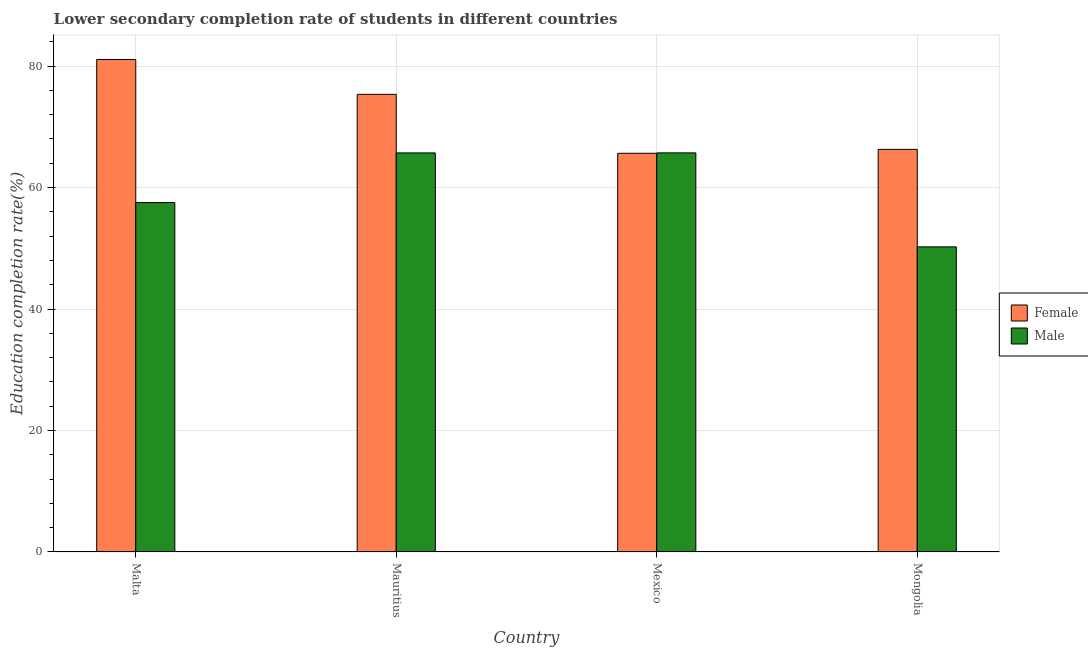How many groups of bars are there?
Offer a terse response. 4. Are the number of bars on each tick of the X-axis equal?
Your answer should be very brief. Yes. How many bars are there on the 2nd tick from the right?
Offer a very short reply. 2. What is the label of the 1st group of bars from the left?
Ensure brevity in your answer.  Malta. In how many cases, is the number of bars for a given country not equal to the number of legend labels?
Ensure brevity in your answer.  0. What is the education completion rate of male students in Mauritius?
Offer a very short reply. 65.71. Across all countries, what is the maximum education completion rate of female students?
Your answer should be compact. 81.09. Across all countries, what is the minimum education completion rate of male students?
Provide a short and direct response. 50.24. In which country was the education completion rate of female students maximum?
Your answer should be very brief. Malta. What is the total education completion rate of male students in the graph?
Make the answer very short. 239.2. What is the difference between the education completion rate of male students in Malta and that in Mongolia?
Your response must be concise. 7.3. What is the difference between the education completion rate of male students in Mexico and the education completion rate of female students in Mauritius?
Provide a succinct answer. -9.64. What is the average education completion rate of female students per country?
Your response must be concise. 72.09. What is the difference between the education completion rate of male students and education completion rate of female students in Mauritius?
Make the answer very short. -9.64. What is the ratio of the education completion rate of female students in Malta to that in Mexico?
Keep it short and to the point. 1.24. What is the difference between the highest and the second highest education completion rate of male students?
Offer a very short reply. 0.01. What is the difference between the highest and the lowest education completion rate of male students?
Offer a very short reply. 15.48. In how many countries, is the education completion rate of female students greater than the average education completion rate of female students taken over all countries?
Ensure brevity in your answer.  2. What does the 2nd bar from the left in Malta represents?
Offer a terse response. Male. What does the 1st bar from the right in Mongolia represents?
Keep it short and to the point. Male. How many bars are there?
Give a very brief answer. 8. Are all the bars in the graph horizontal?
Offer a terse response. No. What is the difference between two consecutive major ticks on the Y-axis?
Your answer should be very brief. 20. Does the graph contain grids?
Ensure brevity in your answer.  Yes. Where does the legend appear in the graph?
Your response must be concise. Center right. How many legend labels are there?
Your answer should be very brief. 2. What is the title of the graph?
Keep it short and to the point. Lower secondary completion rate of students in different countries. Does "Money lenders" appear as one of the legend labels in the graph?
Make the answer very short. No. What is the label or title of the Y-axis?
Your answer should be compact. Education completion rate(%). What is the Education completion rate(%) of Female in Malta?
Make the answer very short. 81.09. What is the Education completion rate(%) of Male in Malta?
Offer a very short reply. 57.54. What is the Education completion rate(%) of Female in Mauritius?
Your response must be concise. 75.35. What is the Education completion rate(%) of Male in Mauritius?
Provide a succinct answer. 65.71. What is the Education completion rate(%) of Female in Mexico?
Make the answer very short. 65.65. What is the Education completion rate(%) of Male in Mexico?
Offer a terse response. 65.72. What is the Education completion rate(%) of Female in Mongolia?
Ensure brevity in your answer.  66.29. What is the Education completion rate(%) in Male in Mongolia?
Make the answer very short. 50.24. Across all countries, what is the maximum Education completion rate(%) in Female?
Make the answer very short. 81.09. Across all countries, what is the maximum Education completion rate(%) in Male?
Your response must be concise. 65.72. Across all countries, what is the minimum Education completion rate(%) of Female?
Provide a succinct answer. 65.65. Across all countries, what is the minimum Education completion rate(%) in Male?
Keep it short and to the point. 50.24. What is the total Education completion rate(%) in Female in the graph?
Provide a succinct answer. 288.38. What is the total Education completion rate(%) in Male in the graph?
Provide a succinct answer. 239.2. What is the difference between the Education completion rate(%) of Female in Malta and that in Mauritius?
Provide a succinct answer. 5.74. What is the difference between the Education completion rate(%) in Male in Malta and that in Mauritius?
Your answer should be compact. -8.17. What is the difference between the Education completion rate(%) in Female in Malta and that in Mexico?
Provide a succinct answer. 15.45. What is the difference between the Education completion rate(%) in Male in Malta and that in Mexico?
Offer a very short reply. -8.18. What is the difference between the Education completion rate(%) of Female in Malta and that in Mongolia?
Ensure brevity in your answer.  14.8. What is the difference between the Education completion rate(%) in Male in Malta and that in Mongolia?
Your answer should be compact. 7.3. What is the difference between the Education completion rate(%) in Female in Mauritius and that in Mexico?
Your response must be concise. 9.71. What is the difference between the Education completion rate(%) in Male in Mauritius and that in Mexico?
Ensure brevity in your answer.  -0.01. What is the difference between the Education completion rate(%) of Female in Mauritius and that in Mongolia?
Ensure brevity in your answer.  9.06. What is the difference between the Education completion rate(%) in Male in Mauritius and that in Mongolia?
Provide a succinct answer. 15.47. What is the difference between the Education completion rate(%) of Female in Mexico and that in Mongolia?
Your response must be concise. -0.64. What is the difference between the Education completion rate(%) in Male in Mexico and that in Mongolia?
Offer a very short reply. 15.48. What is the difference between the Education completion rate(%) of Female in Malta and the Education completion rate(%) of Male in Mauritius?
Keep it short and to the point. 15.38. What is the difference between the Education completion rate(%) of Female in Malta and the Education completion rate(%) of Male in Mexico?
Make the answer very short. 15.37. What is the difference between the Education completion rate(%) of Female in Malta and the Education completion rate(%) of Male in Mongolia?
Ensure brevity in your answer.  30.85. What is the difference between the Education completion rate(%) in Female in Mauritius and the Education completion rate(%) in Male in Mexico?
Provide a succinct answer. 9.64. What is the difference between the Education completion rate(%) of Female in Mauritius and the Education completion rate(%) of Male in Mongolia?
Give a very brief answer. 25.11. What is the difference between the Education completion rate(%) in Female in Mexico and the Education completion rate(%) in Male in Mongolia?
Provide a short and direct response. 15.41. What is the average Education completion rate(%) in Female per country?
Your response must be concise. 72.09. What is the average Education completion rate(%) in Male per country?
Offer a terse response. 59.8. What is the difference between the Education completion rate(%) of Female and Education completion rate(%) of Male in Malta?
Your answer should be compact. 23.56. What is the difference between the Education completion rate(%) of Female and Education completion rate(%) of Male in Mauritius?
Ensure brevity in your answer.  9.64. What is the difference between the Education completion rate(%) of Female and Education completion rate(%) of Male in Mexico?
Give a very brief answer. -0.07. What is the difference between the Education completion rate(%) of Female and Education completion rate(%) of Male in Mongolia?
Give a very brief answer. 16.05. What is the ratio of the Education completion rate(%) of Female in Malta to that in Mauritius?
Ensure brevity in your answer.  1.08. What is the ratio of the Education completion rate(%) of Male in Malta to that in Mauritius?
Your response must be concise. 0.88. What is the ratio of the Education completion rate(%) in Female in Malta to that in Mexico?
Your answer should be very brief. 1.24. What is the ratio of the Education completion rate(%) of Male in Malta to that in Mexico?
Offer a terse response. 0.88. What is the ratio of the Education completion rate(%) of Female in Malta to that in Mongolia?
Make the answer very short. 1.22. What is the ratio of the Education completion rate(%) of Male in Malta to that in Mongolia?
Provide a succinct answer. 1.15. What is the ratio of the Education completion rate(%) in Female in Mauritius to that in Mexico?
Offer a very short reply. 1.15. What is the ratio of the Education completion rate(%) of Female in Mauritius to that in Mongolia?
Your answer should be very brief. 1.14. What is the ratio of the Education completion rate(%) of Male in Mauritius to that in Mongolia?
Offer a very short reply. 1.31. What is the ratio of the Education completion rate(%) of Female in Mexico to that in Mongolia?
Your answer should be compact. 0.99. What is the ratio of the Education completion rate(%) of Male in Mexico to that in Mongolia?
Provide a short and direct response. 1.31. What is the difference between the highest and the second highest Education completion rate(%) of Female?
Offer a terse response. 5.74. What is the difference between the highest and the second highest Education completion rate(%) in Male?
Make the answer very short. 0.01. What is the difference between the highest and the lowest Education completion rate(%) in Female?
Provide a succinct answer. 15.45. What is the difference between the highest and the lowest Education completion rate(%) of Male?
Give a very brief answer. 15.48. 